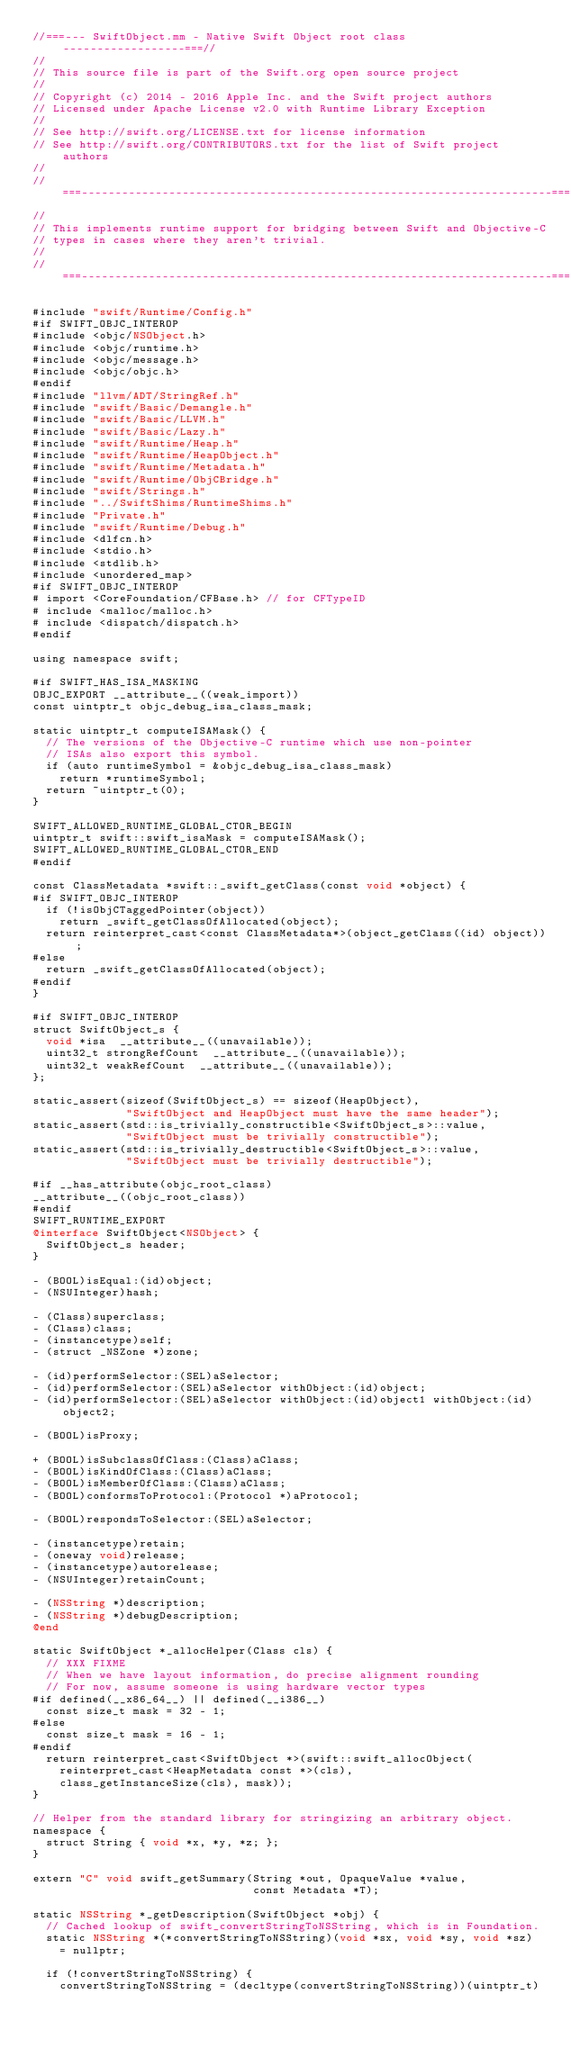Convert code to text. <code><loc_0><loc_0><loc_500><loc_500><_ObjectiveC_>//===--- SwiftObject.mm - Native Swift Object root class ------------------===//
//
// This source file is part of the Swift.org open source project
//
// Copyright (c) 2014 - 2016 Apple Inc. and the Swift project authors
// Licensed under Apache License v2.0 with Runtime Library Exception
//
// See http://swift.org/LICENSE.txt for license information
// See http://swift.org/CONTRIBUTORS.txt for the list of Swift project authors
//
//===----------------------------------------------------------------------===//
//
// This implements runtime support for bridging between Swift and Objective-C
// types in cases where they aren't trivial.
//
//===----------------------------------------------------------------------===//

#include "swift/Runtime/Config.h"
#if SWIFT_OBJC_INTEROP
#include <objc/NSObject.h>
#include <objc/runtime.h>
#include <objc/message.h>
#include <objc/objc.h>
#endif
#include "llvm/ADT/StringRef.h"
#include "swift/Basic/Demangle.h"
#include "swift/Basic/LLVM.h"
#include "swift/Basic/Lazy.h"
#include "swift/Runtime/Heap.h"
#include "swift/Runtime/HeapObject.h"
#include "swift/Runtime/Metadata.h"
#include "swift/Runtime/ObjCBridge.h"
#include "swift/Strings.h"
#include "../SwiftShims/RuntimeShims.h"
#include "Private.h"
#include "swift/Runtime/Debug.h"
#include <dlfcn.h>
#include <stdio.h>
#include <stdlib.h>
#include <unordered_map>
#if SWIFT_OBJC_INTEROP
# import <CoreFoundation/CFBase.h> // for CFTypeID
# include <malloc/malloc.h>
# include <dispatch/dispatch.h>
#endif

using namespace swift;

#if SWIFT_HAS_ISA_MASKING
OBJC_EXPORT __attribute__((weak_import))
const uintptr_t objc_debug_isa_class_mask;

static uintptr_t computeISAMask() {
  // The versions of the Objective-C runtime which use non-pointer
  // ISAs also export this symbol.
  if (auto runtimeSymbol = &objc_debug_isa_class_mask)
    return *runtimeSymbol;
  return ~uintptr_t(0);
}

SWIFT_ALLOWED_RUNTIME_GLOBAL_CTOR_BEGIN
uintptr_t swift::swift_isaMask = computeISAMask();
SWIFT_ALLOWED_RUNTIME_GLOBAL_CTOR_END
#endif

const ClassMetadata *swift::_swift_getClass(const void *object) {
#if SWIFT_OBJC_INTEROP
  if (!isObjCTaggedPointer(object))
    return _swift_getClassOfAllocated(object);
  return reinterpret_cast<const ClassMetadata*>(object_getClass((id) object));
#else
  return _swift_getClassOfAllocated(object);
#endif
}

#if SWIFT_OBJC_INTEROP
struct SwiftObject_s {
  void *isa  __attribute__((unavailable));
  uint32_t strongRefCount  __attribute__((unavailable));
  uint32_t weakRefCount  __attribute__((unavailable));
};

static_assert(sizeof(SwiftObject_s) == sizeof(HeapObject),
              "SwiftObject and HeapObject must have the same header");
static_assert(std::is_trivially_constructible<SwiftObject_s>::value,
              "SwiftObject must be trivially constructible");
static_assert(std::is_trivially_destructible<SwiftObject_s>::value,
              "SwiftObject must be trivially destructible");

#if __has_attribute(objc_root_class)
__attribute__((objc_root_class))
#endif
SWIFT_RUNTIME_EXPORT
@interface SwiftObject<NSObject> {
  SwiftObject_s header;
}

- (BOOL)isEqual:(id)object;
- (NSUInteger)hash;

- (Class)superclass;
- (Class)class;
- (instancetype)self;
- (struct _NSZone *)zone;

- (id)performSelector:(SEL)aSelector;
- (id)performSelector:(SEL)aSelector withObject:(id)object;
- (id)performSelector:(SEL)aSelector withObject:(id)object1 withObject:(id)object2;

- (BOOL)isProxy;

+ (BOOL)isSubclassOfClass:(Class)aClass;
- (BOOL)isKindOfClass:(Class)aClass;
- (BOOL)isMemberOfClass:(Class)aClass;
- (BOOL)conformsToProtocol:(Protocol *)aProtocol;

- (BOOL)respondsToSelector:(SEL)aSelector;

- (instancetype)retain;
- (oneway void)release;
- (instancetype)autorelease;
- (NSUInteger)retainCount;

- (NSString *)description;
- (NSString *)debugDescription;
@end

static SwiftObject *_allocHelper(Class cls) {
  // XXX FIXME
  // When we have layout information, do precise alignment rounding
  // For now, assume someone is using hardware vector types
#if defined(__x86_64__) || defined(__i386__)
  const size_t mask = 32 - 1;
#else
  const size_t mask = 16 - 1;
#endif
  return reinterpret_cast<SwiftObject *>(swift::swift_allocObject(
    reinterpret_cast<HeapMetadata const *>(cls),
    class_getInstanceSize(cls), mask));
}

// Helper from the standard library for stringizing an arbitrary object.
namespace {
  struct String { void *x, *y, *z; };
}

extern "C" void swift_getSummary(String *out, OpaqueValue *value,
                                 const Metadata *T);

static NSString *_getDescription(SwiftObject *obj) {
  // Cached lookup of swift_convertStringToNSString, which is in Foundation.
  static NSString *(*convertStringToNSString)(void *sx, void *sy, void *sz)
    = nullptr;
  
  if (!convertStringToNSString) {
    convertStringToNSString = (decltype(convertStringToNSString))(uintptr_t)</code> 